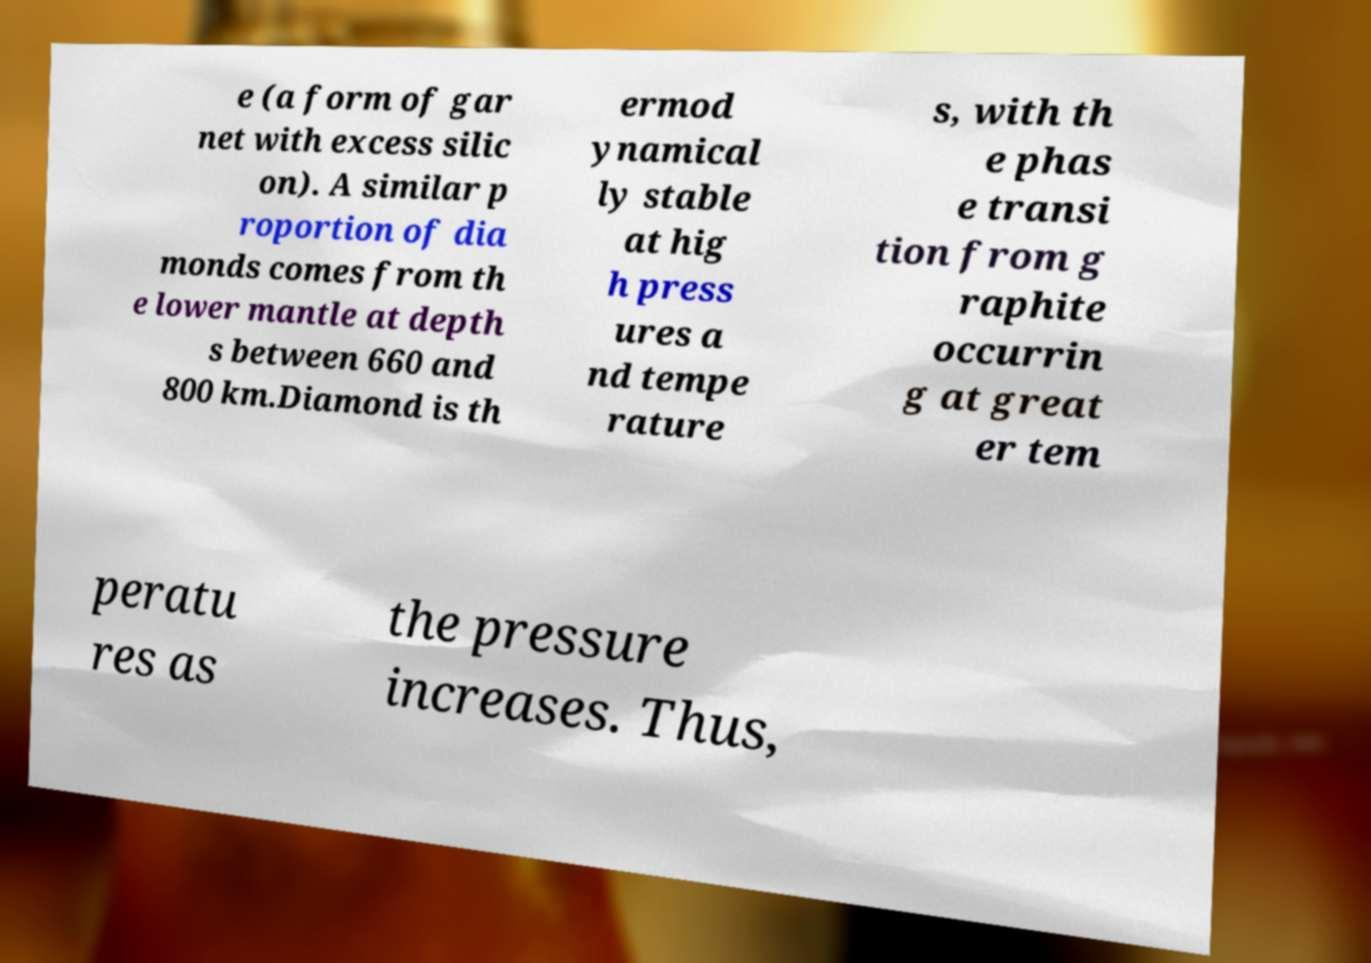Could you extract and type out the text from this image? e (a form of gar net with excess silic on). A similar p roportion of dia monds comes from th e lower mantle at depth s between 660 and 800 km.Diamond is th ermod ynamical ly stable at hig h press ures a nd tempe rature s, with th e phas e transi tion from g raphite occurrin g at great er tem peratu res as the pressure increases. Thus, 